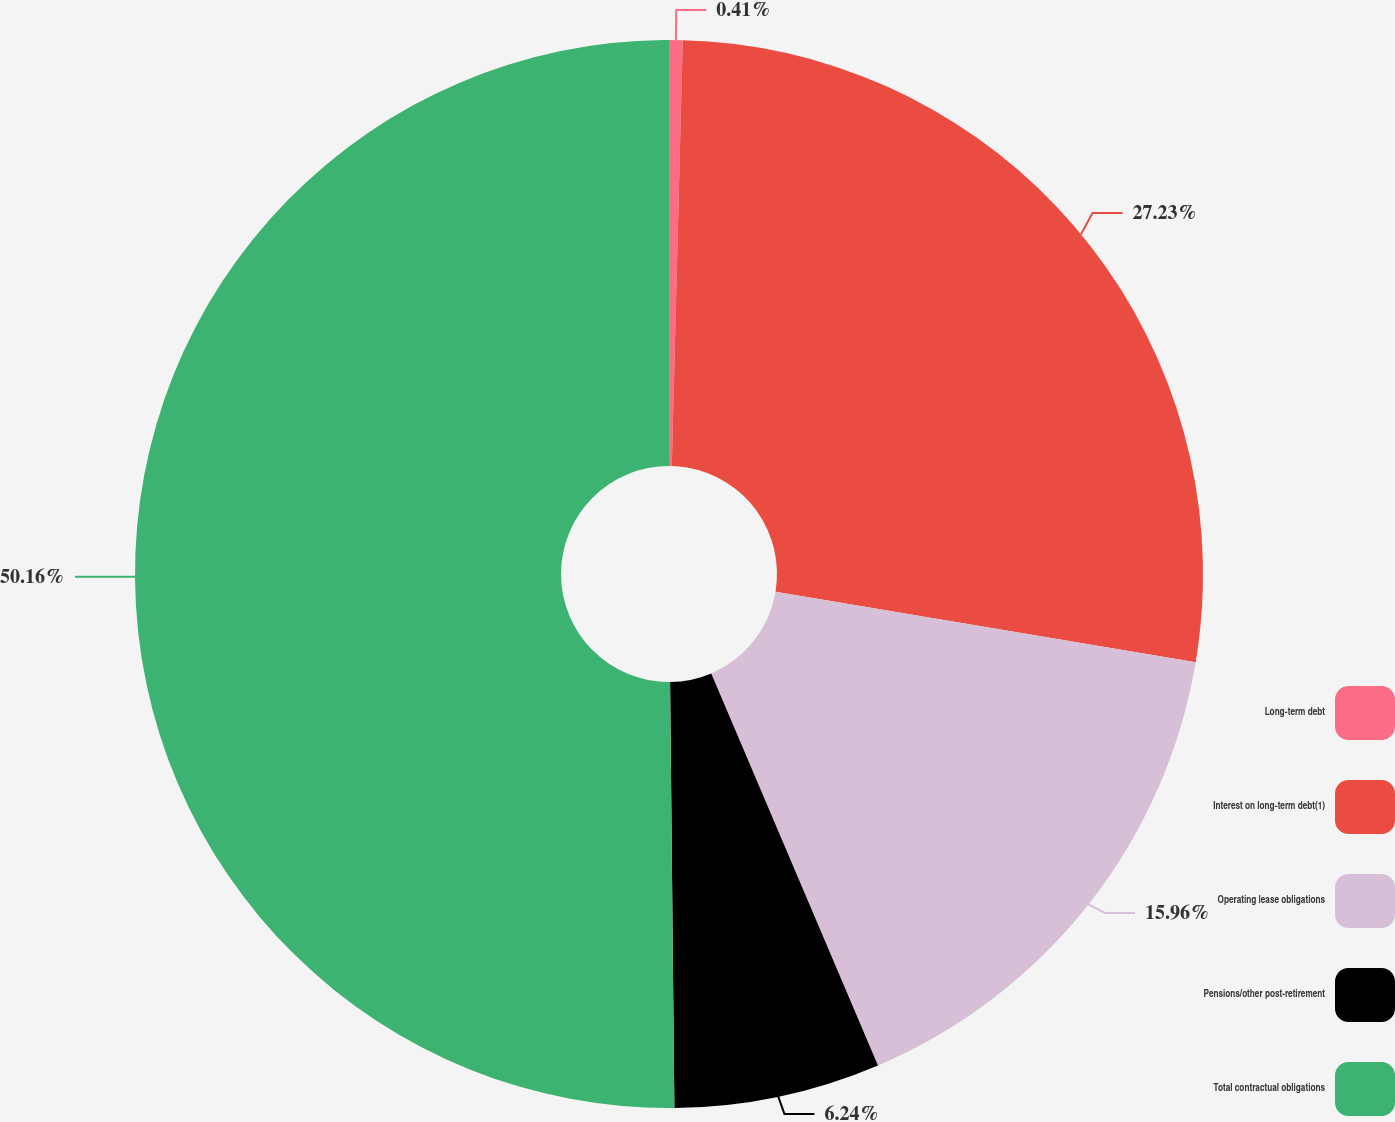Convert chart. <chart><loc_0><loc_0><loc_500><loc_500><pie_chart><fcel>Long-term debt<fcel>Interest on long-term debt(1)<fcel>Operating lease obligations<fcel>Pensions/other post-retirement<fcel>Total contractual obligations<nl><fcel>0.41%<fcel>27.23%<fcel>15.96%<fcel>6.24%<fcel>50.16%<nl></chart> 